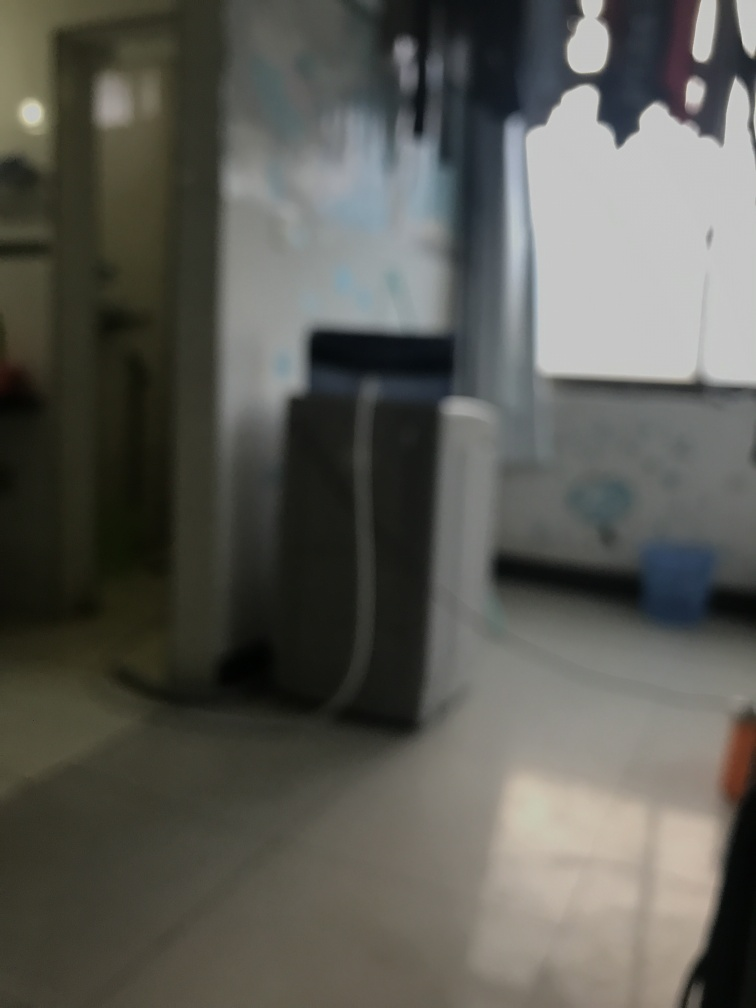What elements in this image might contribute to feeling of this place being inhabited or used? The presence of multiple utility items like a tall white object which could be a refrigerator, a slightly seen trash bin, and a container of possibly wet wipes suggest this space is regularly used or inhabited. Interesting, does the lighting say anything about the time of day or mood in this image? The natural light coming in from the left suggests daylight, likely brightening the space during midday or early afternoon, creating a naturally illuminated but serene indoor atmosphere. 